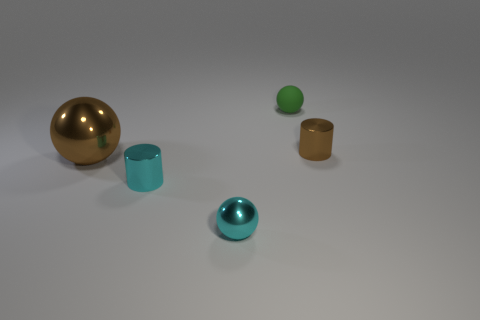Can you tell me which objects are metallic? Certainly, the large gold sphere and the smaller teal sphere exhibit characteristics of metallic objects, such as a shiny, reflective surface that is indicative of metals. And which of these objects appears to be floating or not in contact with the ground? None of the objects in the image appear to be floating; all of them seem to be resting on the flat surface. 